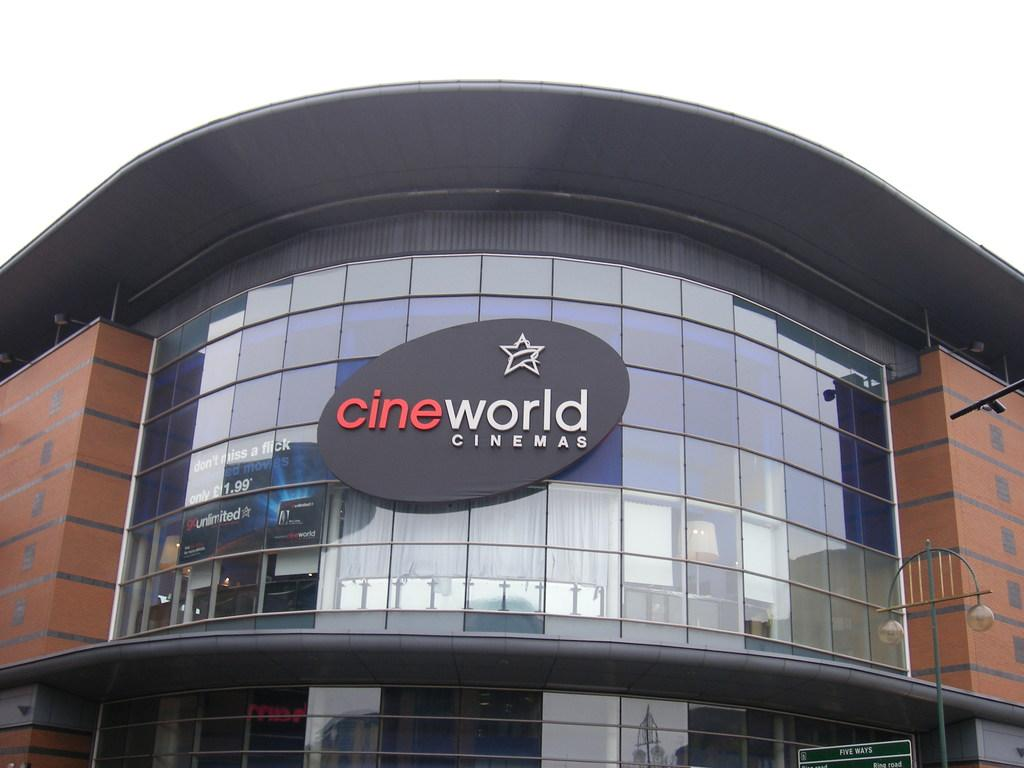What is the main subject in the center of the image? There is a building in the center of the image. What is attached to the building? There is a glass on the building. What is visible at the top of the image? The sky is visible at the top of the image. What can be seen at the right side of the image? There is a light pole at the right side of the image. What hobbies are the protesters engaging in at the afterthought in the image? There are no protesters or afterthoughts present in the image. 